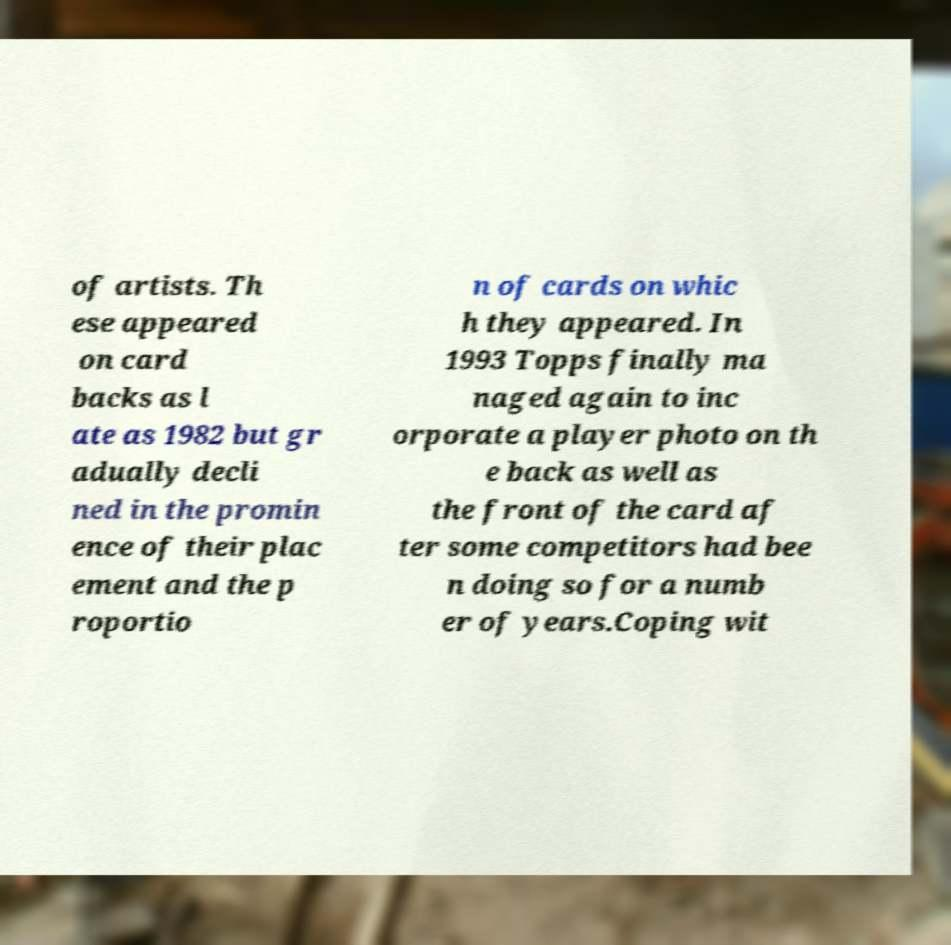Please read and relay the text visible in this image. What does it say? of artists. Th ese appeared on card backs as l ate as 1982 but gr adually decli ned in the promin ence of their plac ement and the p roportio n of cards on whic h they appeared. In 1993 Topps finally ma naged again to inc orporate a player photo on th e back as well as the front of the card af ter some competitors had bee n doing so for a numb er of years.Coping wit 